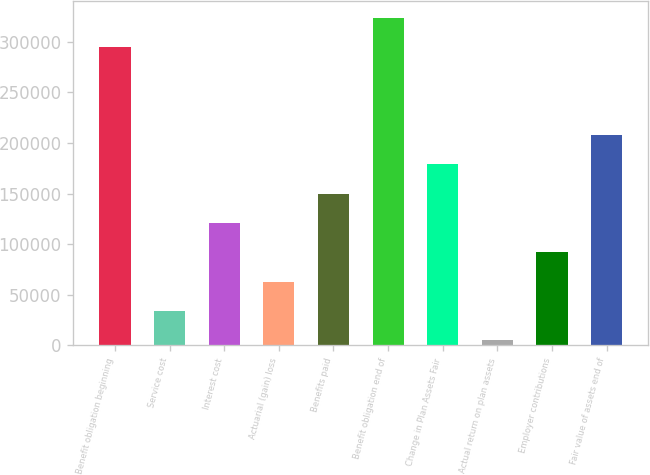Convert chart to OTSL. <chart><loc_0><loc_0><loc_500><loc_500><bar_chart><fcel>Benefit obligation beginning<fcel>Service cost<fcel>Interest cost<fcel>Actuarial (gain) loss<fcel>Benefits paid<fcel>Benefit obligation end of<fcel>Change in Plan Assets Fair<fcel>Actual return on plan assets<fcel>Employer contributions<fcel>Fair value of assets end of<nl><fcel>294730<fcel>34165.6<fcel>121020<fcel>63117.2<fcel>149972<fcel>323682<fcel>178924<fcel>5214<fcel>92068.8<fcel>207875<nl></chart> 